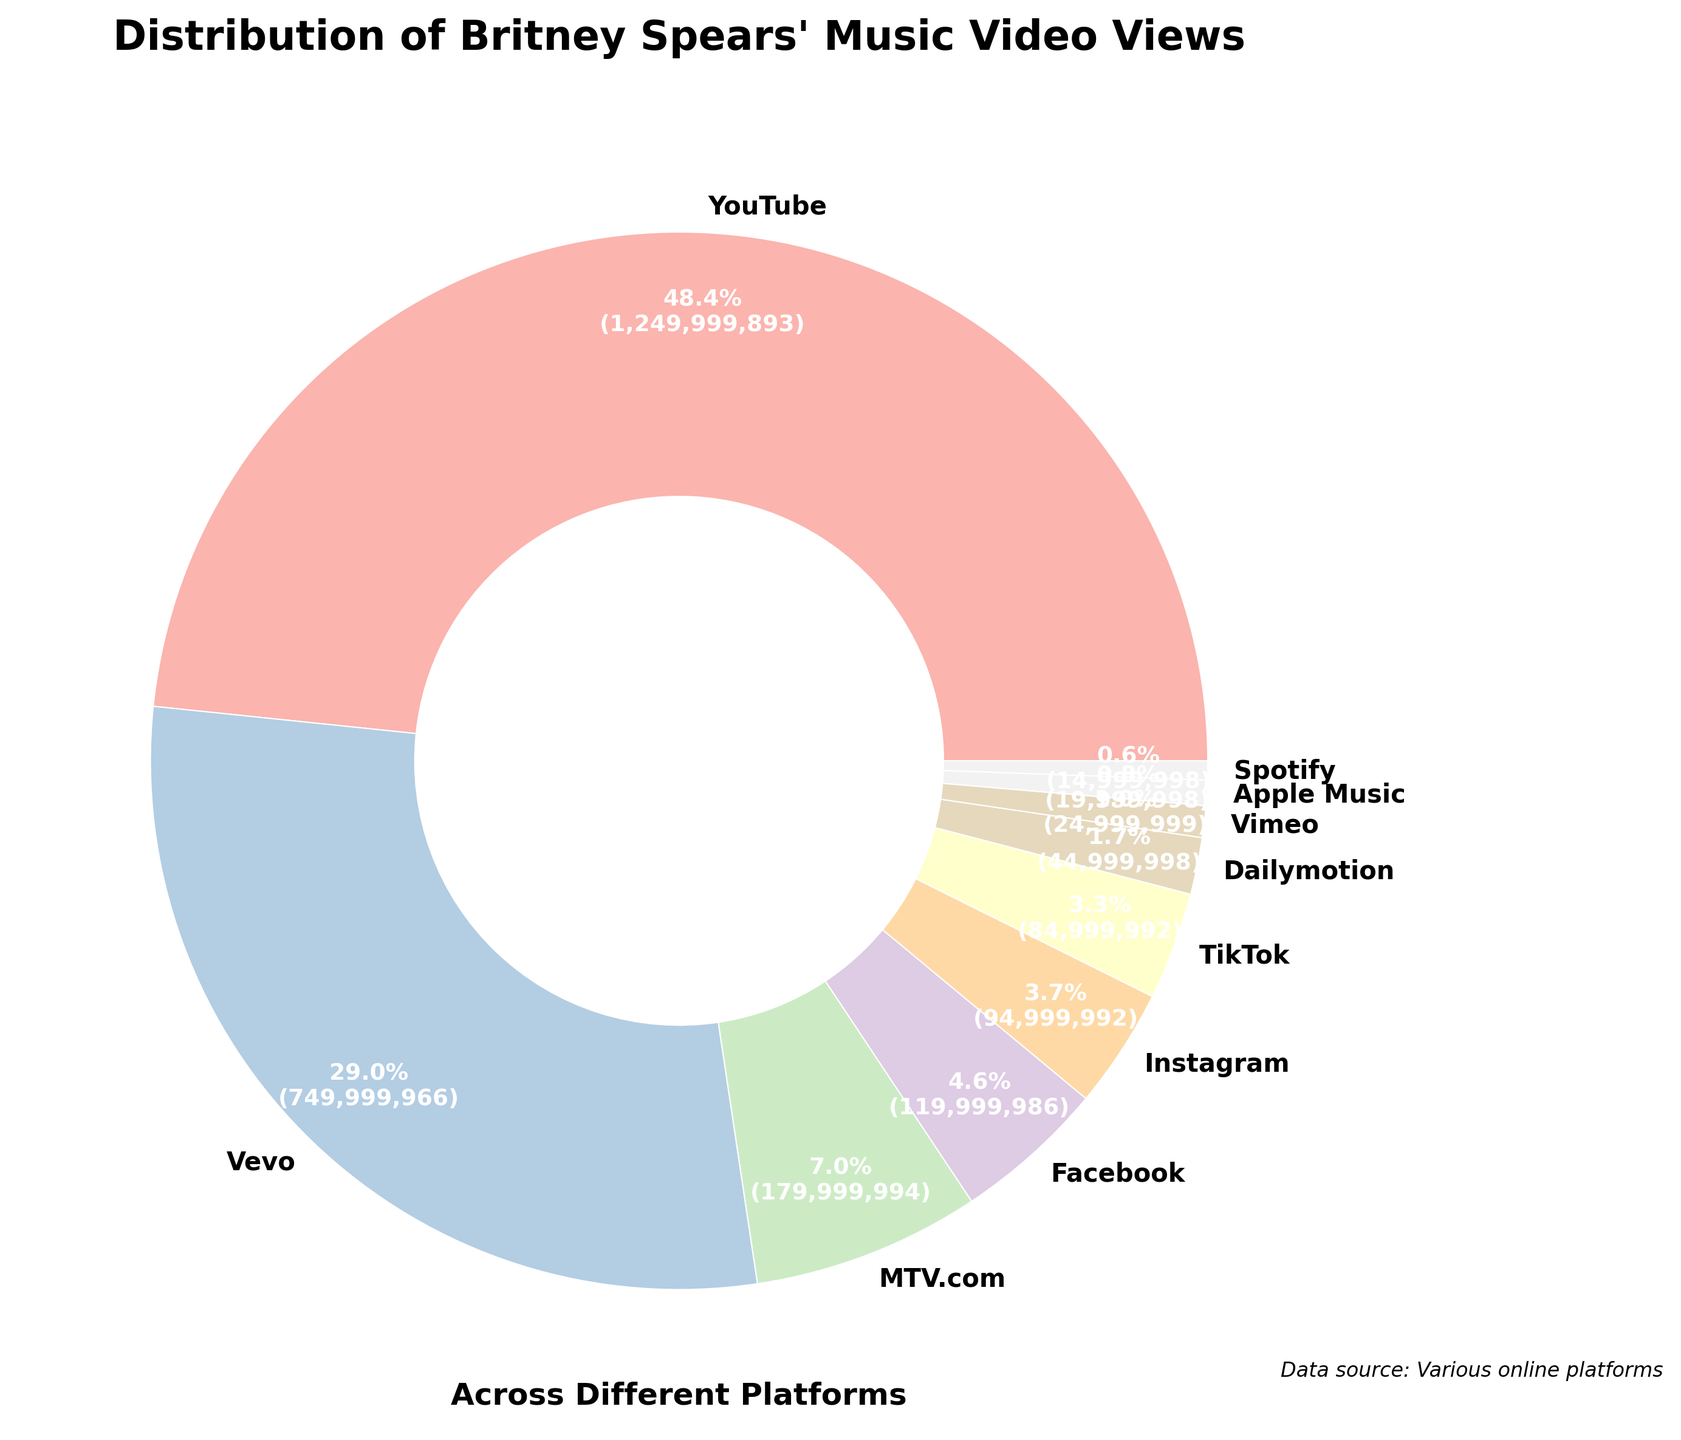What's the largest platform for Britney Spears' music video views? The figure shows that YouTube has the largest slice of the pie chart, indicating it has the most views compared to other platforms.
Answer: YouTube Which platform has fewer views: Instagram or TikTok? By looking at the size of the slices, Instagram's total views are depicted with a slightly larger slice compared to TikTok, indicating TikTok has fewer views.
Answer: TikTok What is the combined percentage of music video views from Facebook and Instagram? From the pie chart, Facebook accounts for 120,000,000 views and Instagram for 95,000,000 views. The total views are 1,550,000,000. To find the combined percentage, [(120,000,000 + 95,000,000) / 1,550,000,000] * 100, which equates to approximately 13.87%.
Answer: 13.87% Which platform has a bigger percentage of views: Vimeo or Dailymotion? The pie chart slice for Dailymotion is bigger than Vimeo, indicating Dailymotion has a larger percentage of views.
Answer: Dailymotion How many more views does the platform with the most views have compared to the platform with the least views? The platform with the most views is YouTube (1,250,000,000 views) and the platform with the least views is Spotify (15,000,000 views). The difference is 1,250,000,000 - 15,000,000 = 1,235,000,000 views.
Answer: 1,235,000,000 What is the percentage share of Apple Music views? By observing the pie chart, Apple Music has 20,000,000 views. The total views are 1,550,000,000, so the percentage is (20,000,000 / 1,550,000,000) * 100, which is approximately 1.29%.
Answer: 1.29% How does the size of the Vevo slice compare to the size of the MTV.com slice? The pie chart shows the Vevo slice is larger than the MTV.com slice, meaning Vevo has more views.
Answer: Vevo If you sum the views of MTV.com, Facebook, and Instagram, what percentage of total views do they represent? MTV.com has 180,000,000 views, Facebook has 120,000,000 views, and Instagram has 95,000,000 views. Their combined views are 395,000,000. The total views are 1,550,000,000. Therefore, the percentage is (395,000,000 / 1,550,000,000) * 100, which is approximately 25.48%.
Answer: 25.48% 